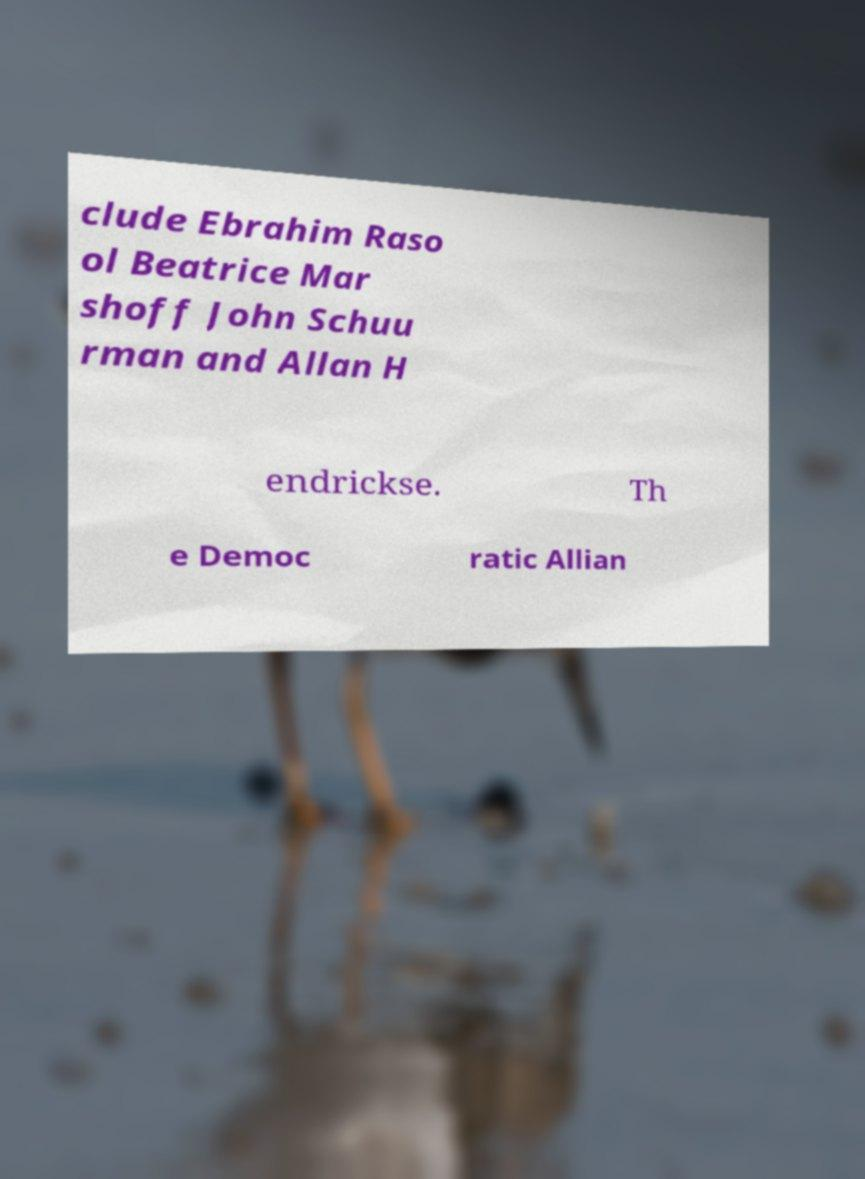Could you extract and type out the text from this image? clude Ebrahim Raso ol Beatrice Mar shoff John Schuu rman and Allan H endrickse. Th e Democ ratic Allian 